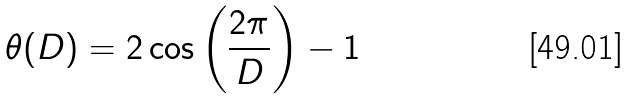<formula> <loc_0><loc_0><loc_500><loc_500>\theta ( D ) = 2 \cos \left ( \frac { 2 \pi } { D } \right ) - 1</formula> 